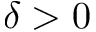<formula> <loc_0><loc_0><loc_500><loc_500>\delta > 0</formula> 